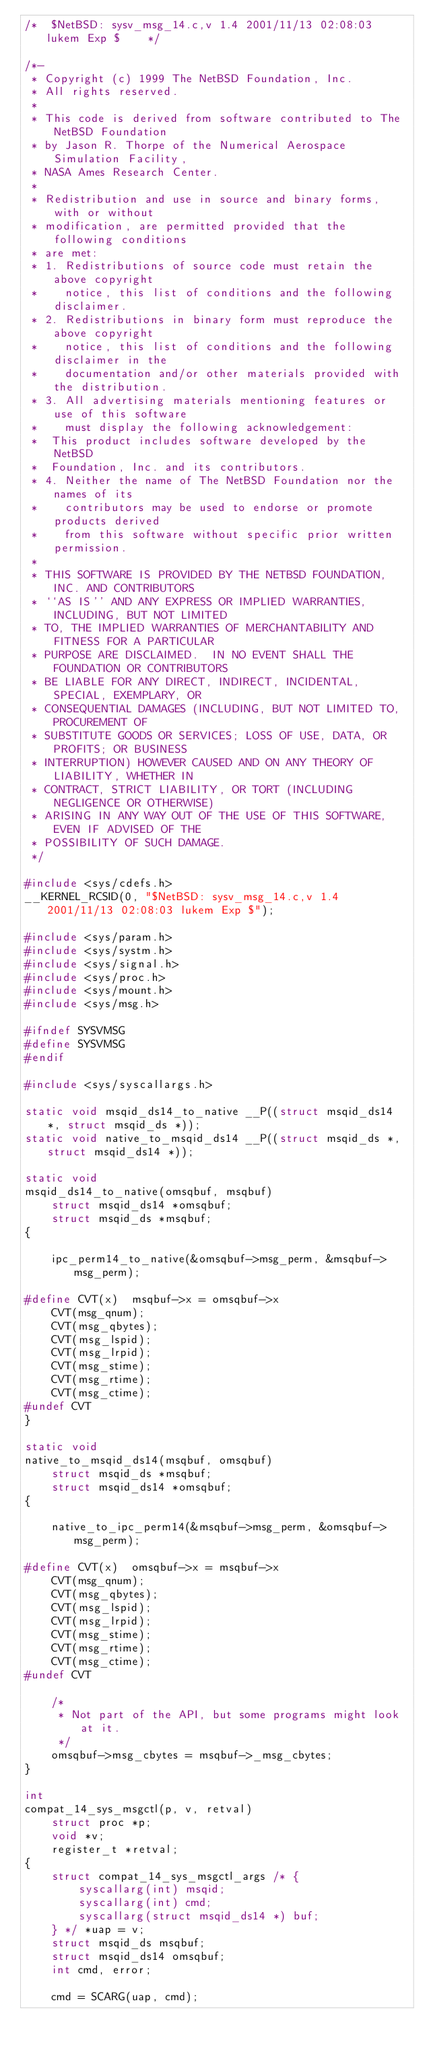Convert code to text. <code><loc_0><loc_0><loc_500><loc_500><_C_>/*	$NetBSD: sysv_msg_14.c,v 1.4 2001/11/13 02:08:03 lukem Exp $	*/

/*-
 * Copyright (c) 1999 The NetBSD Foundation, Inc.
 * All rights reserved.
 *
 * This code is derived from software contributed to The NetBSD Foundation
 * by Jason R. Thorpe of the Numerical Aerospace Simulation Facility,
 * NASA Ames Research Center.
 *
 * Redistribution and use in source and binary forms, with or without
 * modification, are permitted provided that the following conditions
 * are met:
 * 1. Redistributions of source code must retain the above copyright
 *    notice, this list of conditions and the following disclaimer.
 * 2. Redistributions in binary form must reproduce the above copyright
 *    notice, this list of conditions and the following disclaimer in the
 *    documentation and/or other materials provided with the distribution.
 * 3. All advertising materials mentioning features or use of this software
 *    must display the following acknowledgement:
 *	This product includes software developed by the NetBSD
 *	Foundation, Inc. and its contributors.
 * 4. Neither the name of The NetBSD Foundation nor the names of its
 *    contributors may be used to endorse or promote products derived
 *    from this software without specific prior written permission.
 *
 * THIS SOFTWARE IS PROVIDED BY THE NETBSD FOUNDATION, INC. AND CONTRIBUTORS
 * ``AS IS'' AND ANY EXPRESS OR IMPLIED WARRANTIES, INCLUDING, BUT NOT LIMITED
 * TO, THE IMPLIED WARRANTIES OF MERCHANTABILITY AND FITNESS FOR A PARTICULAR
 * PURPOSE ARE DISCLAIMED.  IN NO EVENT SHALL THE FOUNDATION OR CONTRIBUTORS
 * BE LIABLE FOR ANY DIRECT, INDIRECT, INCIDENTAL, SPECIAL, EXEMPLARY, OR
 * CONSEQUENTIAL DAMAGES (INCLUDING, BUT NOT LIMITED TO, PROCUREMENT OF
 * SUBSTITUTE GOODS OR SERVICES; LOSS OF USE, DATA, OR PROFITS; OR BUSINESS
 * INTERRUPTION) HOWEVER CAUSED AND ON ANY THEORY OF LIABILITY, WHETHER IN
 * CONTRACT, STRICT LIABILITY, OR TORT (INCLUDING NEGLIGENCE OR OTHERWISE)
 * ARISING IN ANY WAY OUT OF THE USE OF THIS SOFTWARE, EVEN IF ADVISED OF THE
 * POSSIBILITY OF SUCH DAMAGE.
 */

#include <sys/cdefs.h>
__KERNEL_RCSID(0, "$NetBSD: sysv_msg_14.c,v 1.4 2001/11/13 02:08:03 lukem Exp $");

#include <sys/param.h>
#include <sys/systm.h>
#include <sys/signal.h>
#include <sys/proc.h>
#include <sys/mount.h>
#include <sys/msg.h>

#ifndef SYSVMSG
#define	SYSVMSG
#endif

#include <sys/syscallargs.h>

static void msqid_ds14_to_native __P((struct msqid_ds14 *, struct msqid_ds *));
static void native_to_msqid_ds14 __P((struct msqid_ds *, struct msqid_ds14 *));

static void
msqid_ds14_to_native(omsqbuf, msqbuf)
	struct msqid_ds14 *omsqbuf;
	struct msqid_ds *msqbuf;
{

	ipc_perm14_to_native(&omsqbuf->msg_perm, &msqbuf->msg_perm);

#define	CVT(x)	msqbuf->x = omsqbuf->x
	CVT(msg_qnum);
	CVT(msg_qbytes);
	CVT(msg_lspid);
	CVT(msg_lrpid);
	CVT(msg_stime);
	CVT(msg_rtime);
	CVT(msg_ctime);
#undef CVT
}

static void
native_to_msqid_ds14(msqbuf, omsqbuf)
	struct msqid_ds *msqbuf;
	struct msqid_ds14 *omsqbuf;
{

	native_to_ipc_perm14(&msqbuf->msg_perm, &omsqbuf->msg_perm);

#define	CVT(x)	omsqbuf->x = msqbuf->x
	CVT(msg_qnum);
	CVT(msg_qbytes);
	CVT(msg_lspid);
	CVT(msg_lrpid);
	CVT(msg_stime);
	CVT(msg_rtime);
	CVT(msg_ctime);
#undef CVT

	/*
	 * Not part of the API, but some programs might look at it.
	 */
	omsqbuf->msg_cbytes = msqbuf->_msg_cbytes;
}

int
compat_14_sys_msgctl(p, v, retval)
	struct proc *p;
	void *v;
	register_t *retval;
{
	struct compat_14_sys_msgctl_args /* {
		syscallarg(int) msqid;
		syscallarg(int) cmd;
		syscallarg(struct msqid_ds14 *) buf;
	} */ *uap = v;
	struct msqid_ds msqbuf;
	struct msqid_ds14 omsqbuf;
	int cmd, error;

	cmd = SCARG(uap, cmd);
</code> 